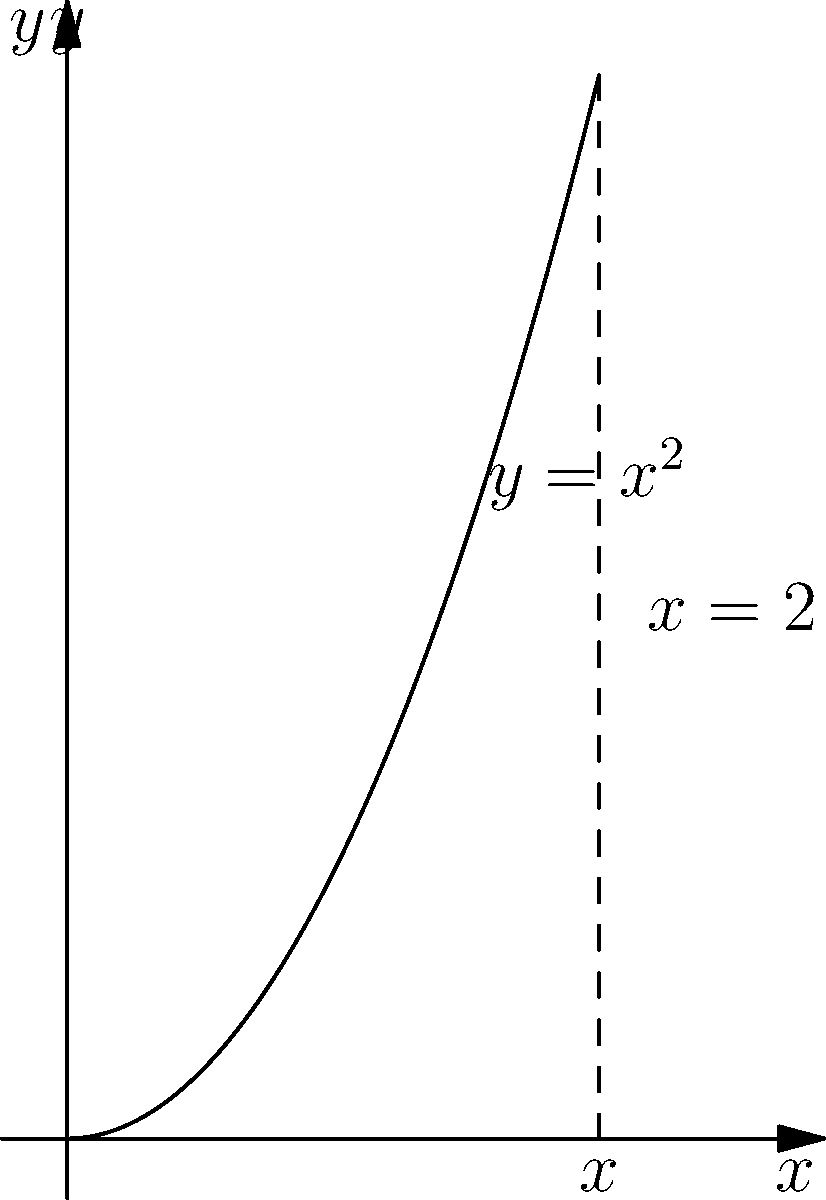As a PowerPoint presentation designer, you're creating a slide about 3D volumes. You need to calculate the volume of the solid formed by rotating the region bounded by $y=x^2$, $y=0$, and $x=2$ around the y-axis. What is the volume of this solid? Let's approach this step-by-step:

1) For rotation around the y-axis, we use the shell method. The formula is:
   $$V = 2\pi \int_a^b x f(x) dx$$

2) In this case:
   - $f(x) = x^2$
   - $a = 0$ (lower bound)
   - $b = 2$ (upper bound)

3) Substituting into the formula:
   $$V = 2\pi \int_0^2 x(x^2) dx = 2\pi \int_0^2 x^3 dx$$

4) Integrate:
   $$V = 2\pi [\frac{x^4}{4}]_0^2$$

5) Evaluate the integral:
   $$V = 2\pi [\frac{2^4}{4} - \frac{0^4}{4}] = 2\pi [\frac{16}{4}] = 2\pi (4) = 8\pi$$

Therefore, the volume of the solid is $8\pi$ cubic units.
Answer: $8\pi$ cubic units 